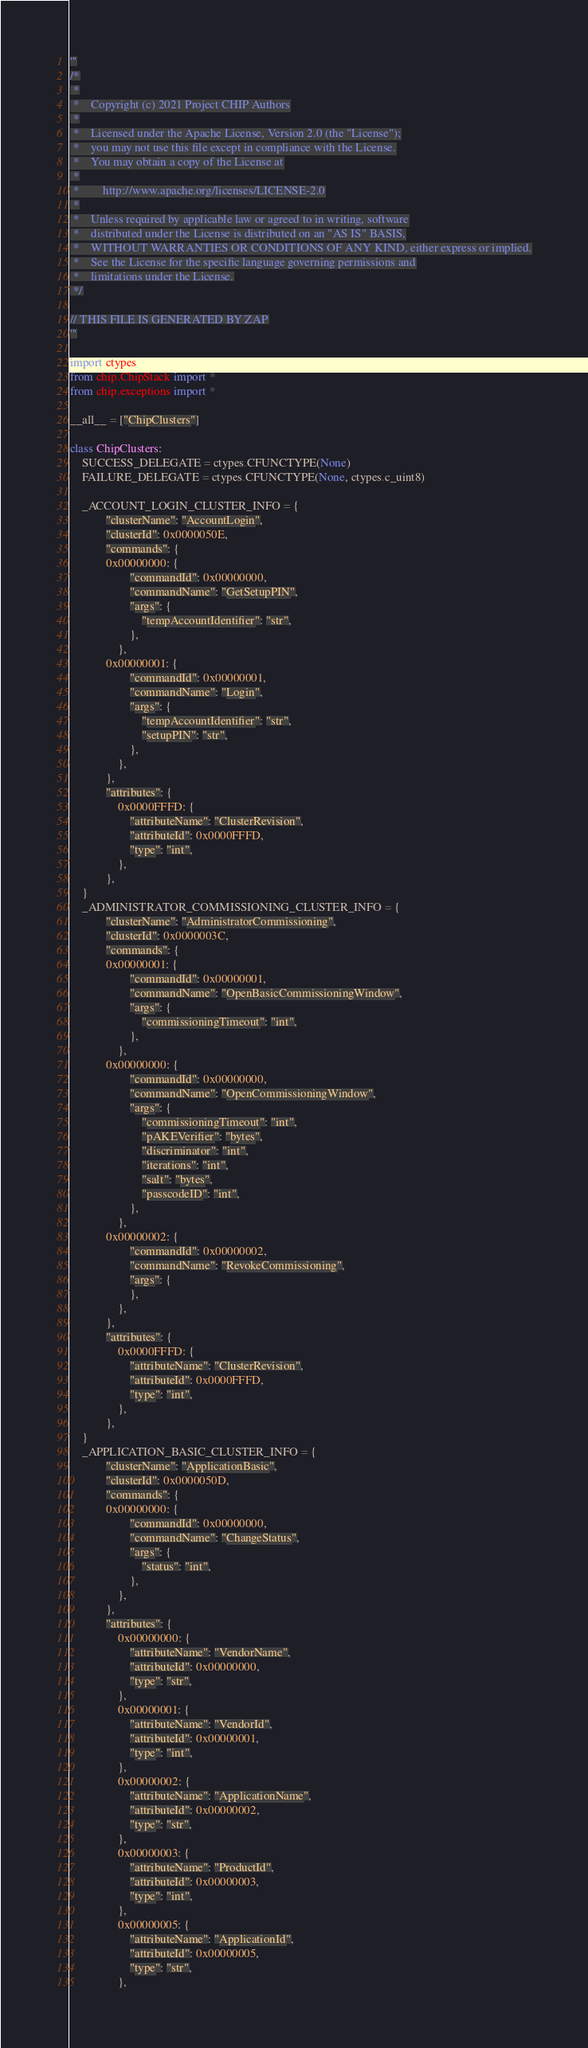Convert code to text. <code><loc_0><loc_0><loc_500><loc_500><_Python_>'''
/*
 *
 *    Copyright (c) 2021 Project CHIP Authors
 *
 *    Licensed under the Apache License, Version 2.0 (the "License");
 *    you may not use this file except in compliance with the License.
 *    You may obtain a copy of the License at
 *
 *        http://www.apache.org/licenses/LICENSE-2.0
 *
 *    Unless required by applicable law or agreed to in writing, software
 *    distributed under the License is distributed on an "AS IS" BASIS,
 *    WITHOUT WARRANTIES OR CONDITIONS OF ANY KIND, either express or implied.
 *    See the License for the specific language governing permissions and
 *    limitations under the License.
 */

// THIS FILE IS GENERATED BY ZAP
'''

import ctypes
from chip.ChipStack import *
from chip.exceptions import *

__all__ = ["ChipClusters"]

class ChipClusters:
    SUCCESS_DELEGATE = ctypes.CFUNCTYPE(None)
    FAILURE_DELEGATE = ctypes.CFUNCTYPE(None, ctypes.c_uint8)

    _ACCOUNT_LOGIN_CLUSTER_INFO = {
            "clusterName": "AccountLogin",
            "clusterId": 0x0000050E,
            "commands": {
            0x00000000: {
                    "commandId": 0x00000000,
                    "commandName": "GetSetupPIN",
                    "args": {
                        "tempAccountIdentifier": "str",
                    },
                },
            0x00000001: {
                    "commandId": 0x00000001,
                    "commandName": "Login",
                    "args": {
                        "tempAccountIdentifier": "str",
                        "setupPIN": "str",
                    },
                },
            },
            "attributes": {
                0x0000FFFD: {
                    "attributeName": "ClusterRevision",
                    "attributeId": 0x0000FFFD,
                    "type": "int",
                },
            },
    }
    _ADMINISTRATOR_COMMISSIONING_CLUSTER_INFO = {
            "clusterName": "AdministratorCommissioning",
            "clusterId": 0x0000003C,
            "commands": {
            0x00000001: {
                    "commandId": 0x00000001,
                    "commandName": "OpenBasicCommissioningWindow",
                    "args": {
                        "commissioningTimeout": "int",
                    },
                },
            0x00000000: {
                    "commandId": 0x00000000,
                    "commandName": "OpenCommissioningWindow",
                    "args": {
                        "commissioningTimeout": "int",
                        "pAKEVerifier": "bytes",
                        "discriminator": "int",
                        "iterations": "int",
                        "salt": "bytes",
                        "passcodeID": "int",
                    },
                },
            0x00000002: {
                    "commandId": 0x00000002,
                    "commandName": "RevokeCommissioning",
                    "args": {
                    },
                },
            },
            "attributes": {
                0x0000FFFD: {
                    "attributeName": "ClusterRevision",
                    "attributeId": 0x0000FFFD,
                    "type": "int",
                },
            },
    }
    _APPLICATION_BASIC_CLUSTER_INFO = {
            "clusterName": "ApplicationBasic",
            "clusterId": 0x0000050D,
            "commands": {
            0x00000000: {
                    "commandId": 0x00000000,
                    "commandName": "ChangeStatus",
                    "args": {
                        "status": "int",
                    },
                },
            },
            "attributes": {
                0x00000000: {
                    "attributeName": "VendorName",
                    "attributeId": 0x00000000,
                    "type": "str",
                },
                0x00000001: {
                    "attributeName": "VendorId",
                    "attributeId": 0x00000001,
                    "type": "int",
                },
                0x00000002: {
                    "attributeName": "ApplicationName",
                    "attributeId": 0x00000002,
                    "type": "str",
                },
                0x00000003: {
                    "attributeName": "ProductId",
                    "attributeId": 0x00000003,
                    "type": "int",
                },
                0x00000005: {
                    "attributeName": "ApplicationId",
                    "attributeId": 0x00000005,
                    "type": "str",
                },</code> 